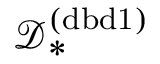<formula> <loc_0><loc_0><loc_500><loc_500>\mathcal { D } _ { * } ^ { ( d b d 1 ) }</formula> 